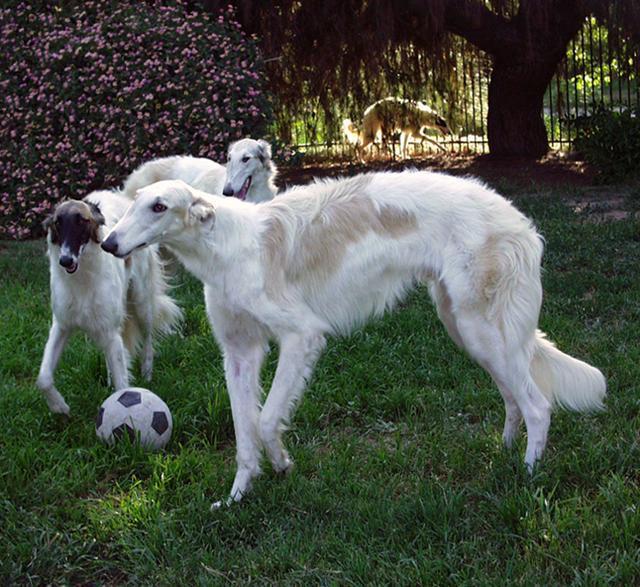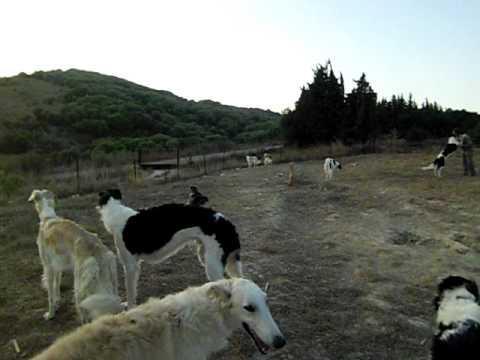The first image is the image on the left, the second image is the image on the right. Given the left and right images, does the statement "An image shows hounds standing on grass with a toy in the scene." hold true? Answer yes or no. Yes. 